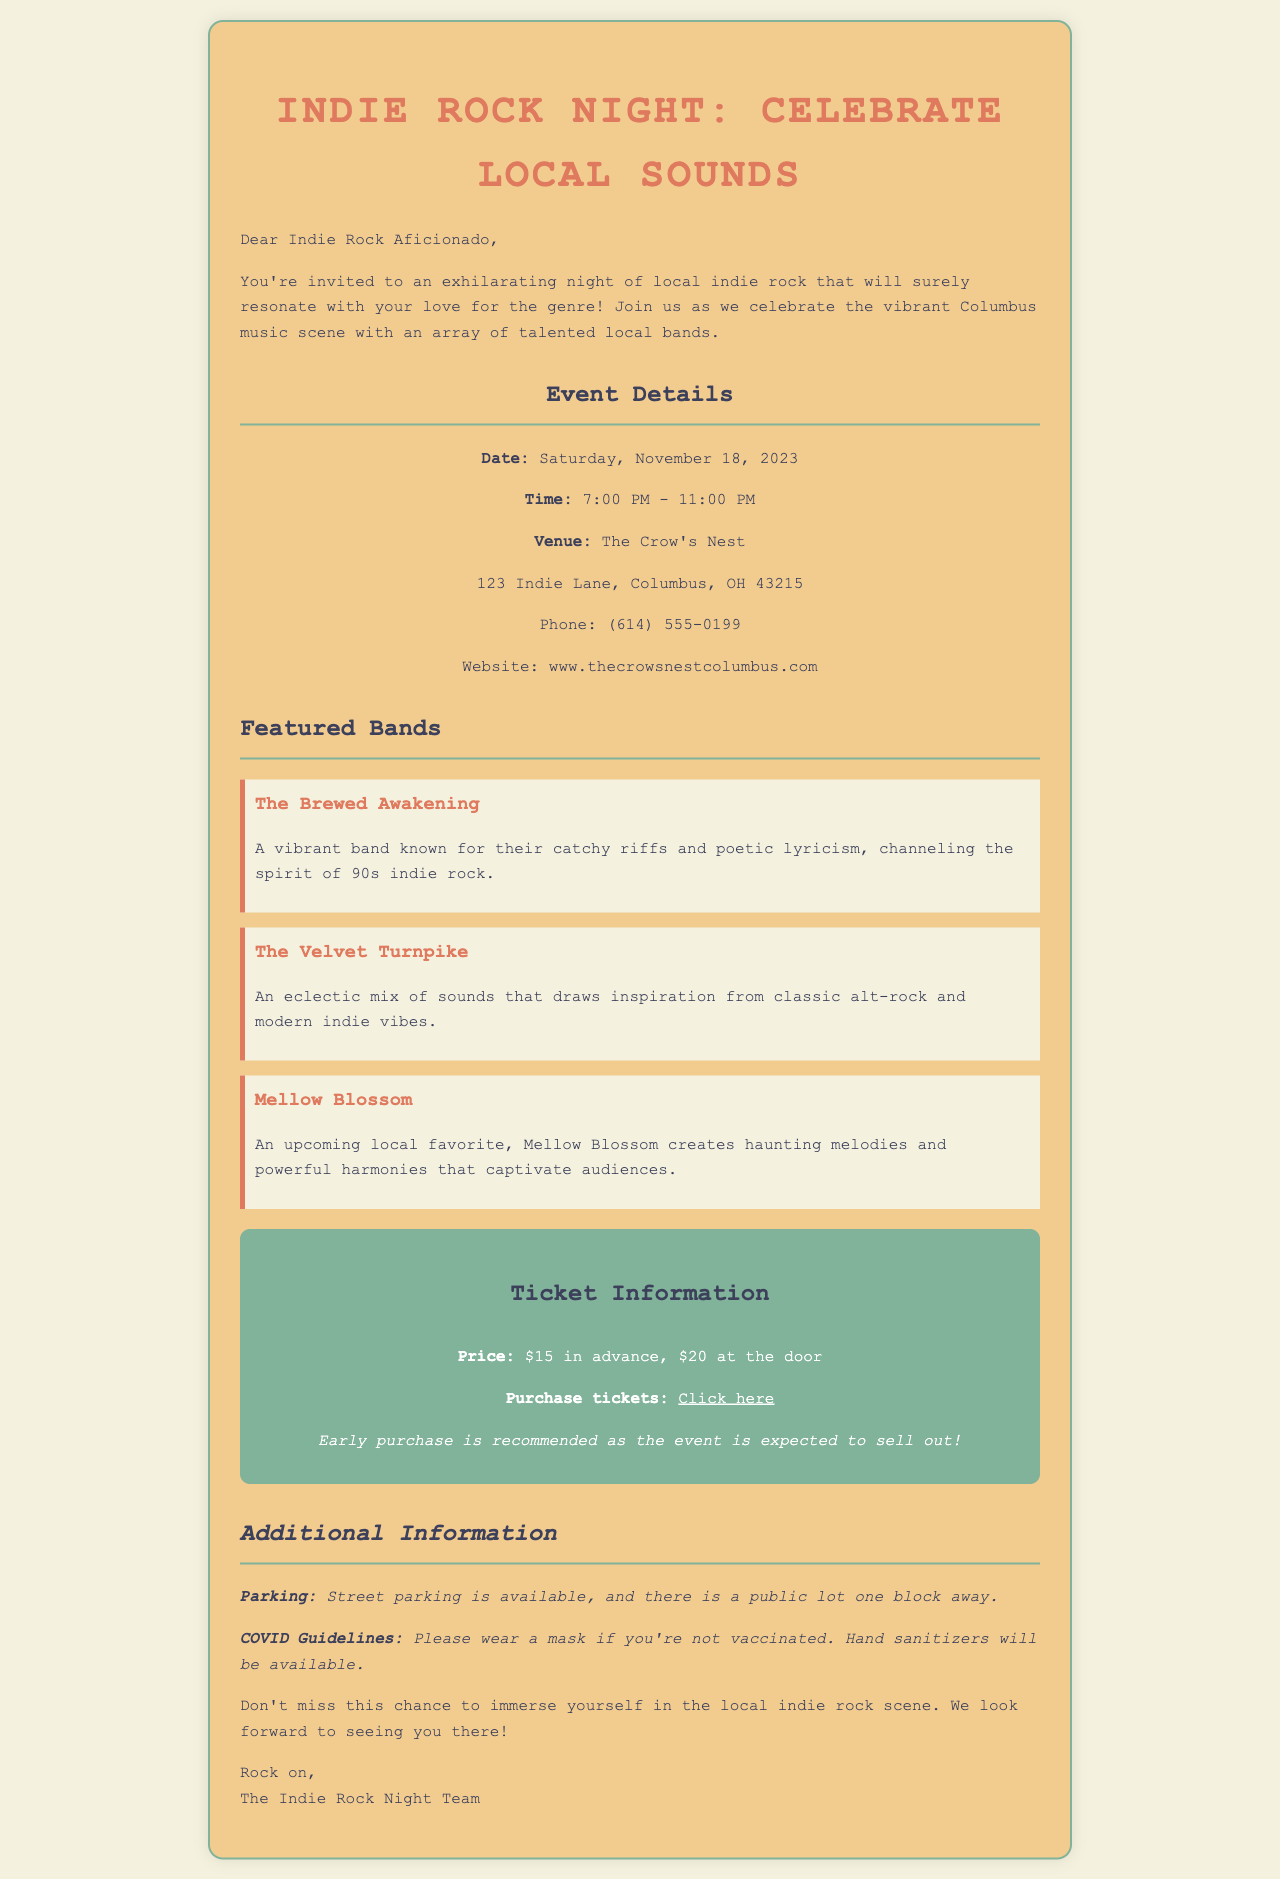what is the event date? The event date is explicitly mentioned in the document as Saturday, November 18, 2023.
Answer: Saturday, November 18, 2023 what is the venue name? The document provides the venue name, which is The Crow's Nest.
Answer: The Crow's Nest how much is the ticket price at the door? The document states that the ticket price at the door is $20, which is specifically mentioned.
Answer: $20 which band is known for their catchy riffs? The Brewed Awakening is highlighted for their catchy riffs and poetic lyricism according to the document.
Answer: The Brewed Awakening what time does the event start? The starting time for the event is listed as 7:00 PM.
Answer: 7:00 PM what is recommended regarding ticket purchase? The document advises early purchase due to the event's expected sell-out, indicating the importance of acting quickly.
Answer: Early purchase is recommended how many bands are featured in the concert? The document lists three bands, detailing their names and descriptions mentioned in the featured section.
Answer: Three bands where is the parking available? The document mentions that street parking is available and specifies the location of a public lot one block away.
Answer: Street parking, public lot one block away what is the primary genre of the concert? The concert primarily showcases local indie rock, which is emphasized in the introductory paragraph of the document.
Answer: Indie rock 